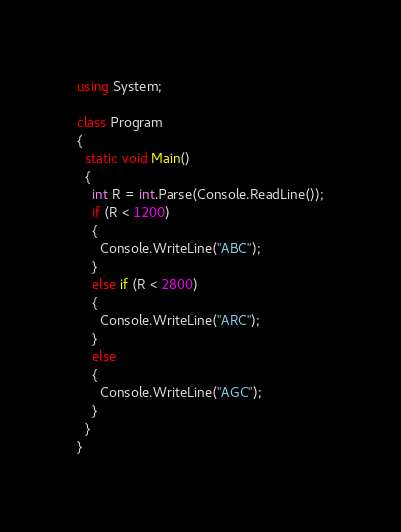Convert code to text. <code><loc_0><loc_0><loc_500><loc_500><_C#_>using System;
 
class Program
{
  static void Main()
  {
    int R = int.Parse(Console.ReadLine());
    if (R < 1200)
    {
      Console.WriteLine("ABC");
    }
    else if (R < 2800)
    {
      Console.WriteLine("ARC");
    }
    else
    {
      Console.WriteLine("AGC");
    }
  }
}</code> 